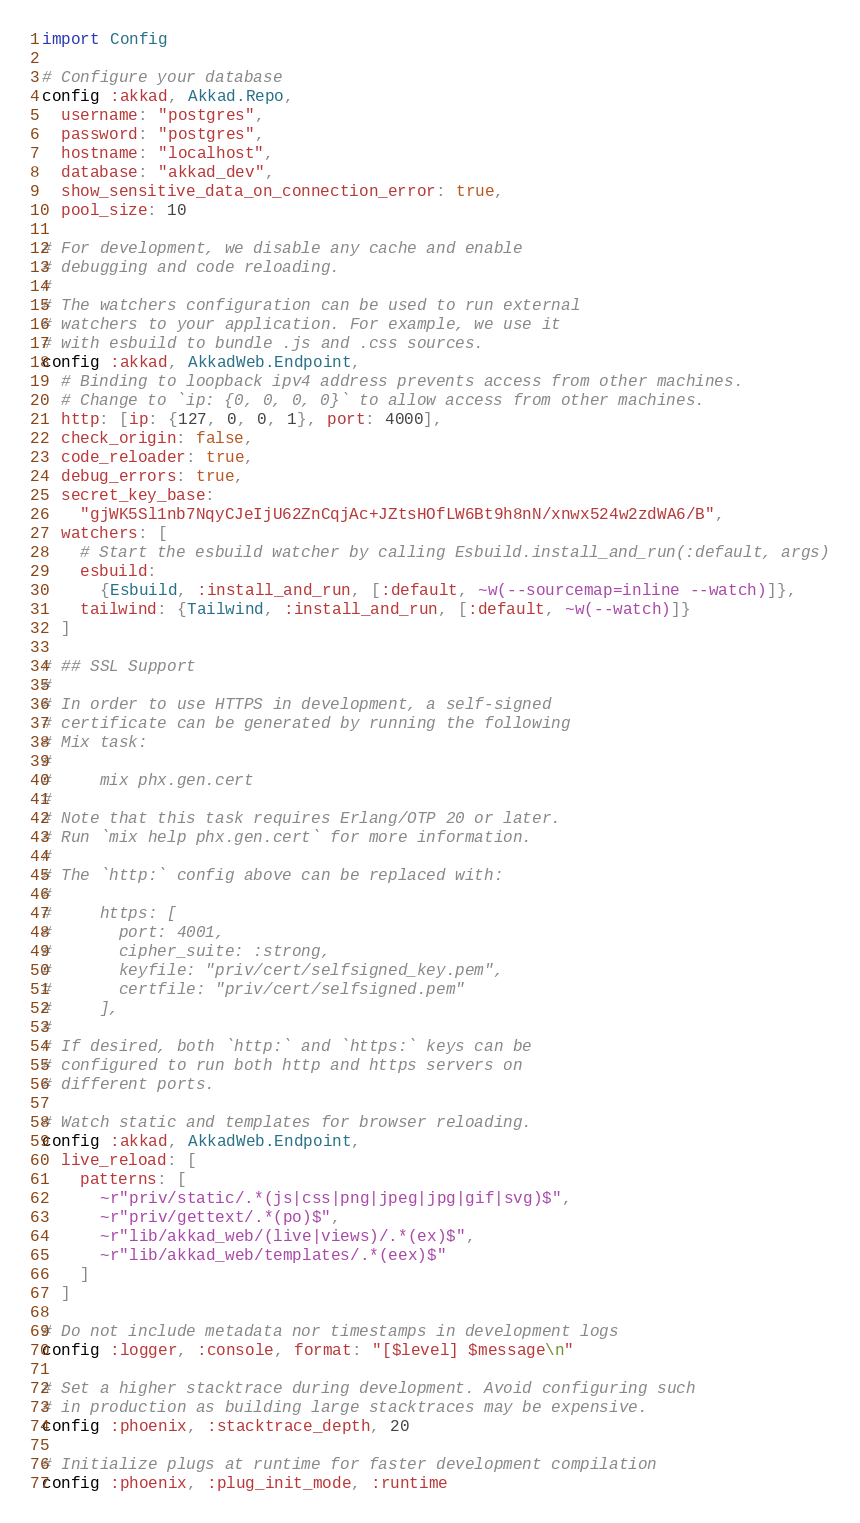<code> <loc_0><loc_0><loc_500><loc_500><_Elixir_>import Config

# Configure your database
config :akkad, Akkad.Repo,
  username: "postgres",
  password: "postgres",
  hostname: "localhost",
  database: "akkad_dev",
  show_sensitive_data_on_connection_error: true,
  pool_size: 10

# For development, we disable any cache and enable
# debugging and code reloading.
#
# The watchers configuration can be used to run external
# watchers to your application. For example, we use it
# with esbuild to bundle .js and .css sources.
config :akkad, AkkadWeb.Endpoint,
  # Binding to loopback ipv4 address prevents access from other machines.
  # Change to `ip: {0, 0, 0, 0}` to allow access from other machines.
  http: [ip: {127, 0, 0, 1}, port: 4000],
  check_origin: false,
  code_reloader: true,
  debug_errors: true,
  secret_key_base:
    "gjWK5Sl1nb7NqyCJeIjU62ZnCqjAc+JZtsHOfLW6Bt9h8nN/xnwx524w2zdWA6/B",
  watchers: [
    # Start the esbuild watcher by calling Esbuild.install_and_run(:default, args)
    esbuild:
      {Esbuild, :install_and_run, [:default, ~w(--sourcemap=inline --watch)]},
    tailwind: {Tailwind, :install_and_run, [:default, ~w(--watch)]}
  ]

# ## SSL Support
#
# In order to use HTTPS in development, a self-signed
# certificate can be generated by running the following
# Mix task:
#
#     mix phx.gen.cert
#
# Note that this task requires Erlang/OTP 20 or later.
# Run `mix help phx.gen.cert` for more information.
#
# The `http:` config above can be replaced with:
#
#     https: [
#       port: 4001,
#       cipher_suite: :strong,
#       keyfile: "priv/cert/selfsigned_key.pem",
#       certfile: "priv/cert/selfsigned.pem"
#     ],
#
# If desired, both `http:` and `https:` keys can be
# configured to run both http and https servers on
# different ports.

# Watch static and templates for browser reloading.
config :akkad, AkkadWeb.Endpoint,
  live_reload: [
    patterns: [
      ~r"priv/static/.*(js|css|png|jpeg|jpg|gif|svg)$",
      ~r"priv/gettext/.*(po)$",
      ~r"lib/akkad_web/(live|views)/.*(ex)$",
      ~r"lib/akkad_web/templates/.*(eex)$"
    ]
  ]

# Do not include metadata nor timestamps in development logs
config :logger, :console, format: "[$level] $message\n"

# Set a higher stacktrace during development. Avoid configuring such
# in production as building large stacktraces may be expensive.
config :phoenix, :stacktrace_depth, 20

# Initialize plugs at runtime for faster development compilation
config :phoenix, :plug_init_mode, :runtime
</code> 